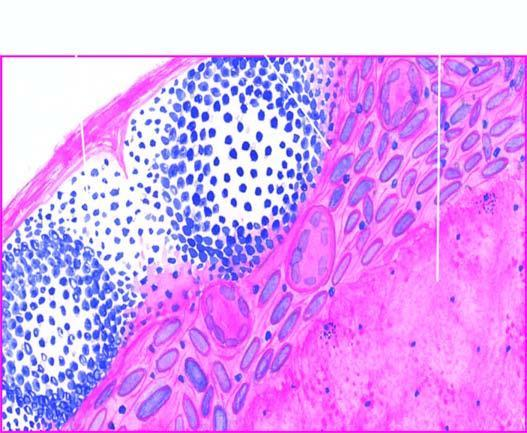s there eosinophilic, amorphous, granular material, while the periphery shows granulomatous inflammation?
Answer the question using a single word or phrase. Yes 